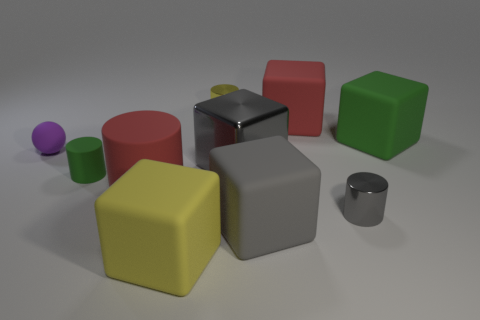Subtract all small cylinders. How many cylinders are left? 1 Subtract all red cylinders. How many cylinders are left? 3 Subtract all spheres. How many objects are left? 9 Subtract all yellow cubes. Subtract all red spheres. How many cubes are left? 4 Subtract all yellow cubes. How many blue cylinders are left? 0 Subtract all blocks. Subtract all large yellow matte objects. How many objects are left? 4 Add 9 gray matte cubes. How many gray matte cubes are left? 10 Add 1 big cyan rubber cubes. How many big cyan rubber cubes exist? 1 Subtract 0 cyan cylinders. How many objects are left? 10 Subtract 1 cylinders. How many cylinders are left? 3 